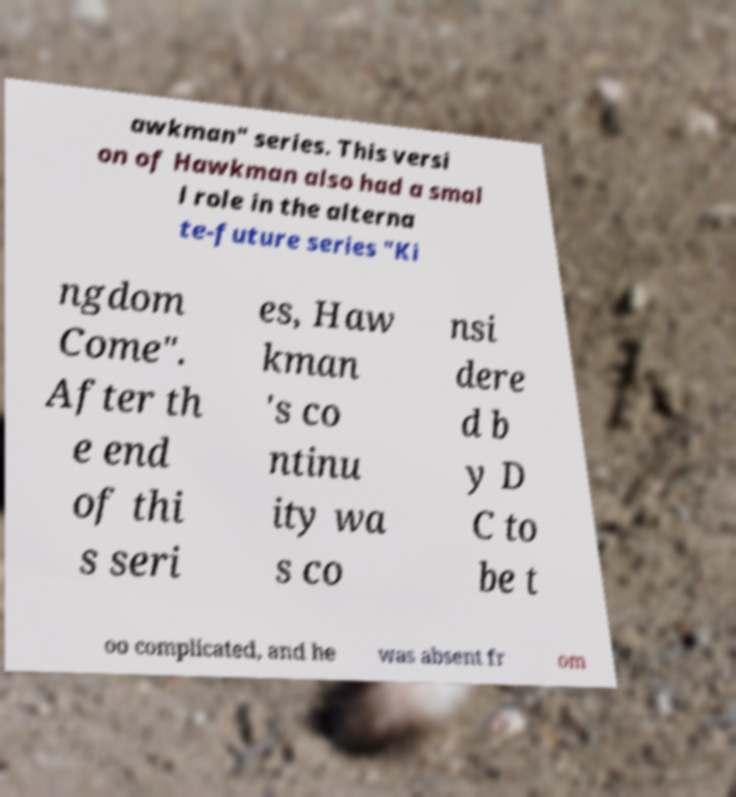Could you extract and type out the text from this image? awkman" series. This versi on of Hawkman also had a smal l role in the alterna te-future series "Ki ngdom Come". After th e end of thi s seri es, Haw kman 's co ntinu ity wa s co nsi dere d b y D C to be t oo complicated, and he was absent fr om 